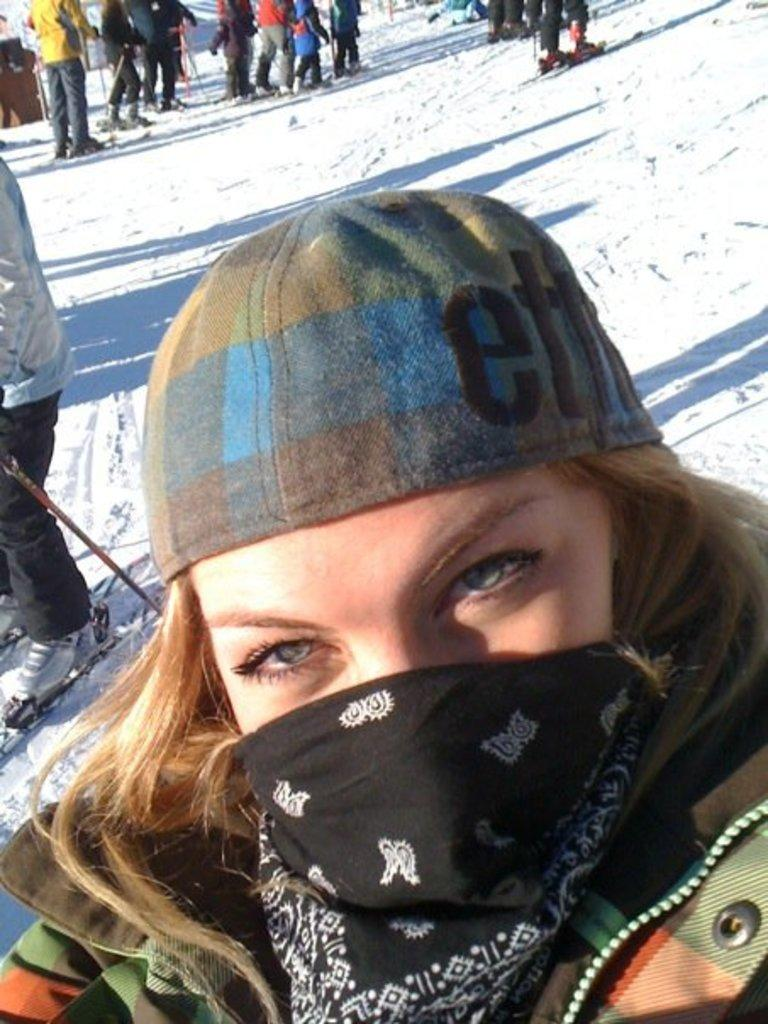Who is present in the image? There is a woman in the image. What is the woman wearing on her head? The woman is wearing a cap. What is covering the woman's face? The woman has a mask on her face. What are the people in the image doing? The people are wearing skis and standing in the snow. What type of silk material is used to make the chair in the image? There is no chair present in the image, so it is not possible to determine the type of silk material used. 